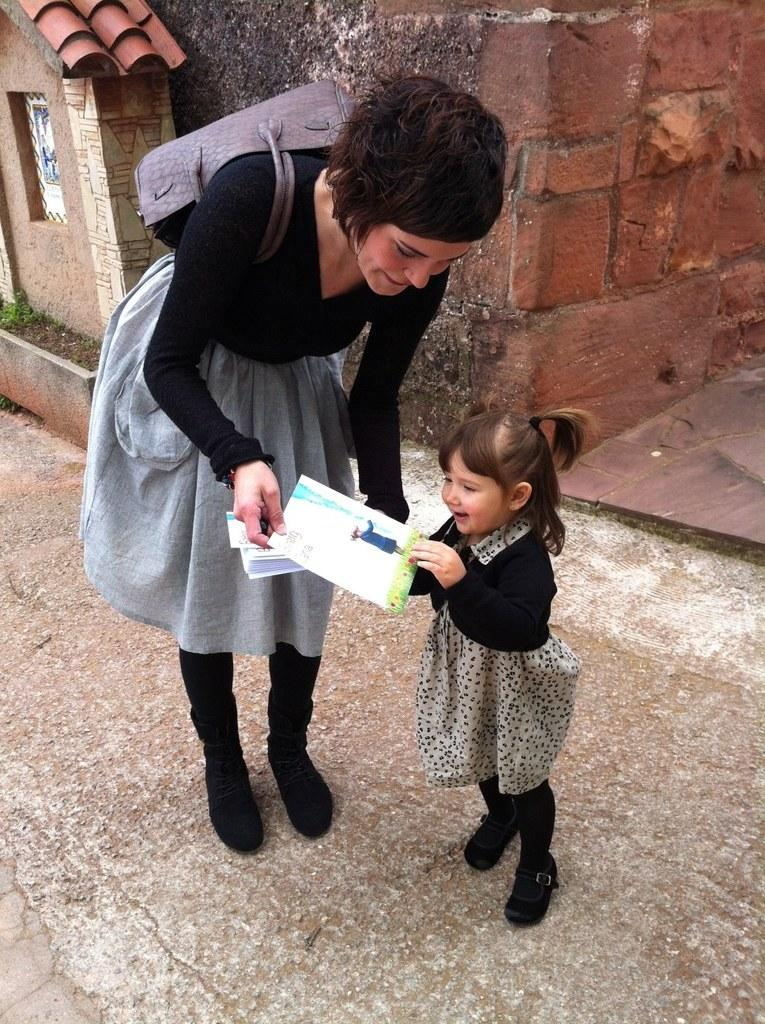What is the baby holding in the image? The baby is holding a paper in the image. Who else is present in the image? There is a woman in the image. What is the woman wearing? The woman is wearing a bag in the image. What is the woman holding? The woman is holding papers in the image. What can be seen in the background of the image? There is a wall visible in the background. What type of car can be seen in the image? There is no car present in the image. How many boys are visible in the image? There are no boys visible in the image; only a baby and a woman are present. 